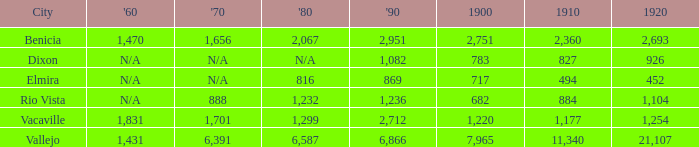What is the 1880 figure when 1860 is N/A and 1910 is 494? 816.0. 